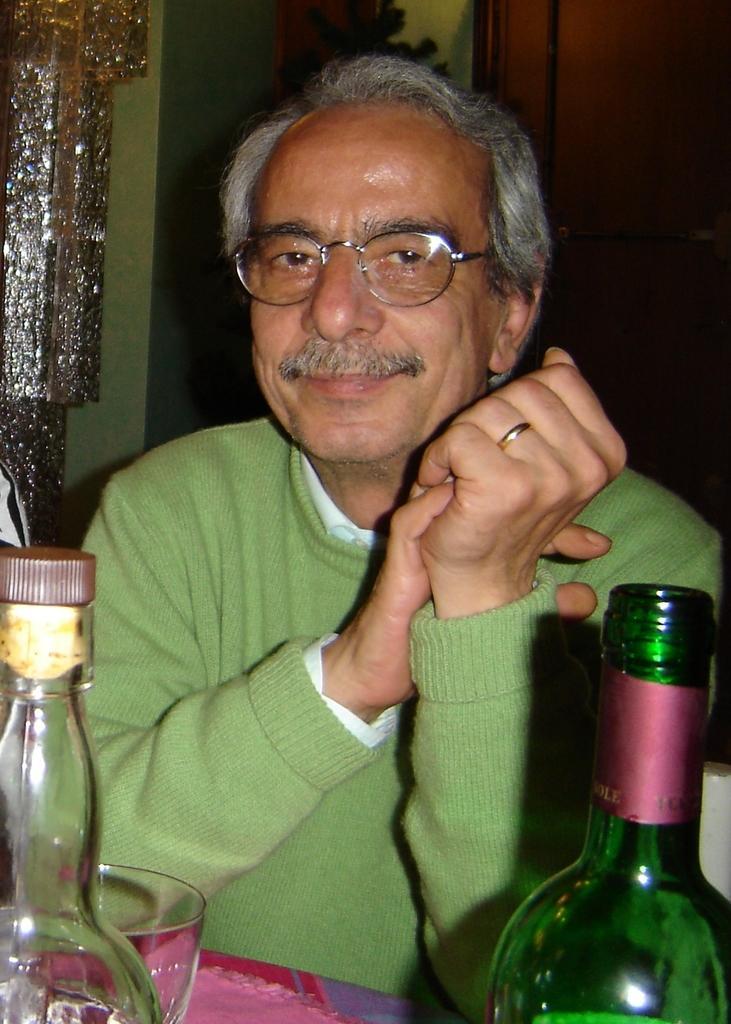Describe this image in one or two sentences. In the image we can see there is a man who is sitting and on table there are wine bottles and a glass. 